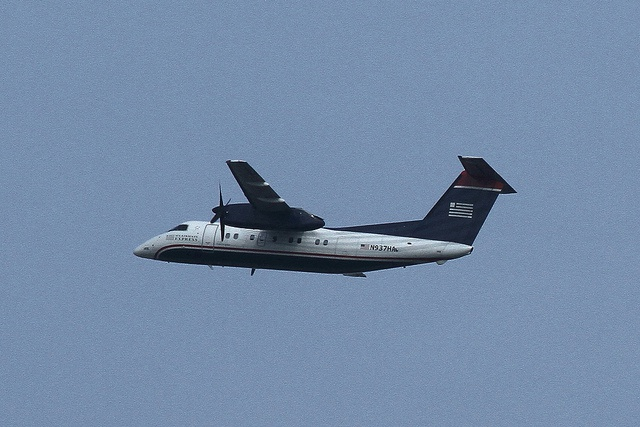Describe the objects in this image and their specific colors. I can see a airplane in gray, black, and darkgray tones in this image. 